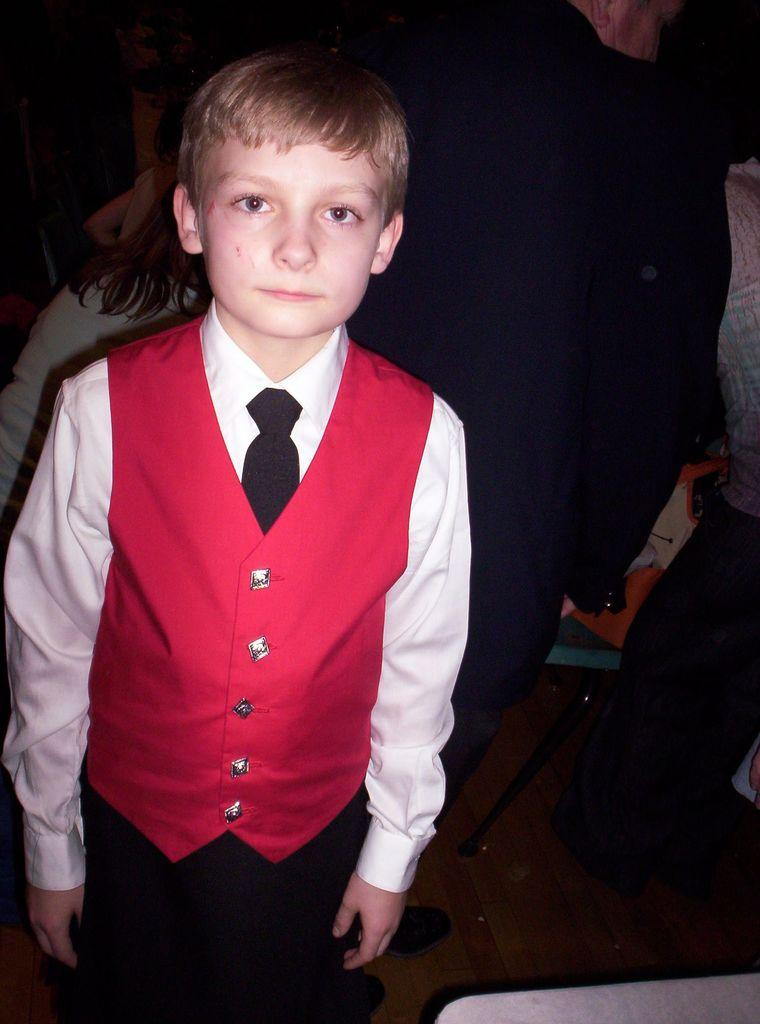Who is the main subject in the image? There is a boy in the image. What is the boy wearing on his upper body? The boy is wearing a white shirt and a red coat. What is the boy wearing around his neck? The boy is wearing a black tie. What is the boy wearing on his lower body? The boy is wearing black pants. What is the boy's posture in the image? The boy is standing. Can you describe the background of the image? There are people in the background of the image. What type of toad can be seen hopping in the image? There is no toad present in the image; it features a boy wearing specific clothing and standing. What is the monetary value of the boy's outfit in the image? The image does not provide information about the monetary value of the boy's outfit. 